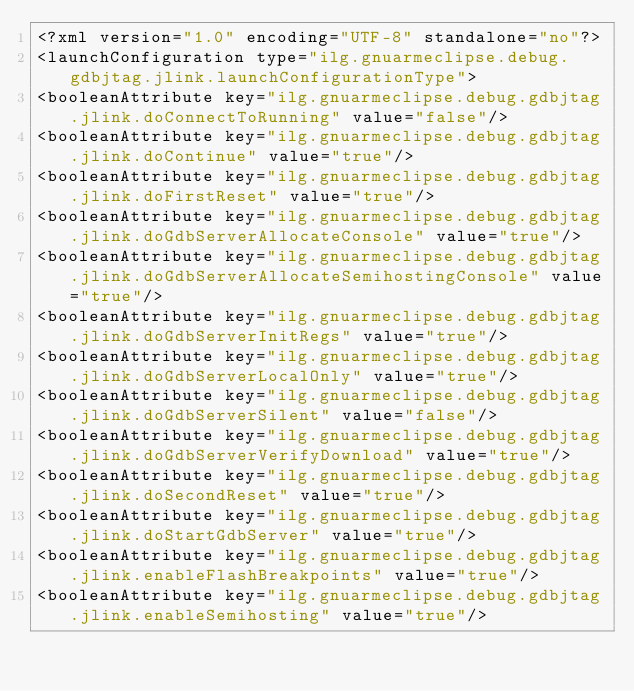<code> <loc_0><loc_0><loc_500><loc_500><_XML_><?xml version="1.0" encoding="UTF-8" standalone="no"?>
<launchConfiguration type="ilg.gnuarmeclipse.debug.gdbjtag.jlink.launchConfigurationType">
<booleanAttribute key="ilg.gnuarmeclipse.debug.gdbjtag.jlink.doConnectToRunning" value="false"/>
<booleanAttribute key="ilg.gnuarmeclipse.debug.gdbjtag.jlink.doContinue" value="true"/>
<booleanAttribute key="ilg.gnuarmeclipse.debug.gdbjtag.jlink.doFirstReset" value="true"/>
<booleanAttribute key="ilg.gnuarmeclipse.debug.gdbjtag.jlink.doGdbServerAllocateConsole" value="true"/>
<booleanAttribute key="ilg.gnuarmeclipse.debug.gdbjtag.jlink.doGdbServerAllocateSemihostingConsole" value="true"/>
<booleanAttribute key="ilg.gnuarmeclipse.debug.gdbjtag.jlink.doGdbServerInitRegs" value="true"/>
<booleanAttribute key="ilg.gnuarmeclipse.debug.gdbjtag.jlink.doGdbServerLocalOnly" value="true"/>
<booleanAttribute key="ilg.gnuarmeclipse.debug.gdbjtag.jlink.doGdbServerSilent" value="false"/>
<booleanAttribute key="ilg.gnuarmeclipse.debug.gdbjtag.jlink.doGdbServerVerifyDownload" value="true"/>
<booleanAttribute key="ilg.gnuarmeclipse.debug.gdbjtag.jlink.doSecondReset" value="true"/>
<booleanAttribute key="ilg.gnuarmeclipse.debug.gdbjtag.jlink.doStartGdbServer" value="true"/>
<booleanAttribute key="ilg.gnuarmeclipse.debug.gdbjtag.jlink.enableFlashBreakpoints" value="true"/>
<booleanAttribute key="ilg.gnuarmeclipse.debug.gdbjtag.jlink.enableSemihosting" value="true"/></code> 